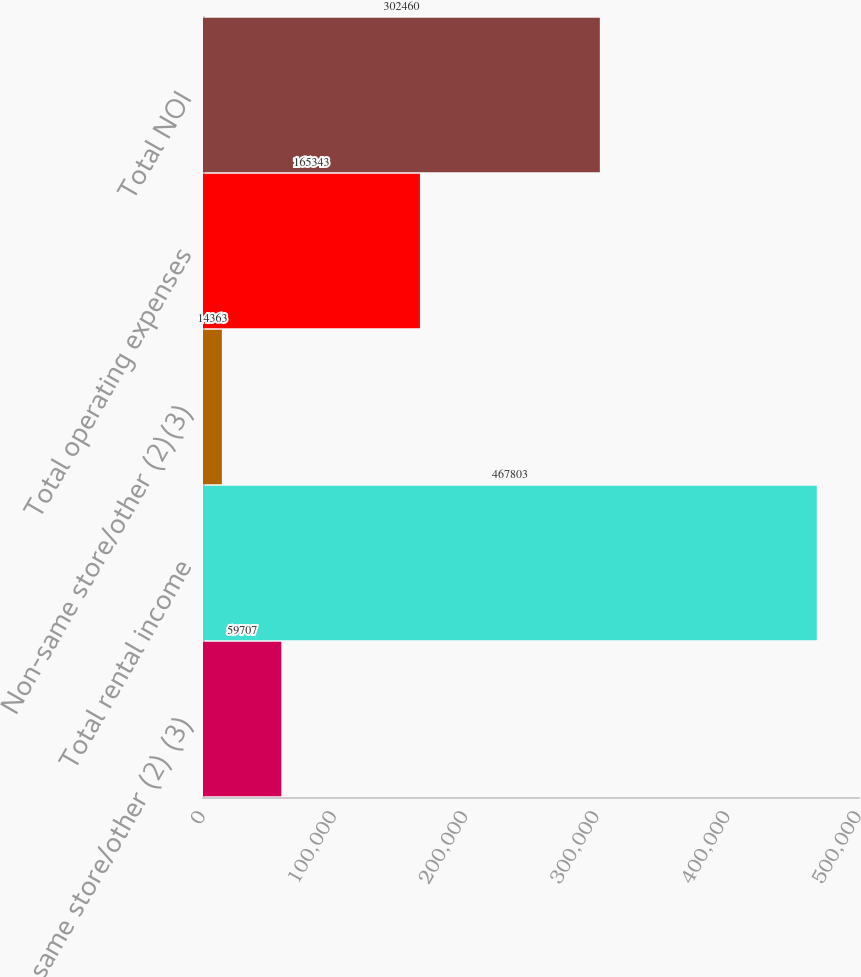Convert chart to OTSL. <chart><loc_0><loc_0><loc_500><loc_500><bar_chart><fcel>Non-same store/other (2) (3)<fcel>Total rental income<fcel>Non-same store/other (2)(3)<fcel>Total operating expenses<fcel>Total NOI<nl><fcel>59707<fcel>467803<fcel>14363<fcel>165343<fcel>302460<nl></chart> 